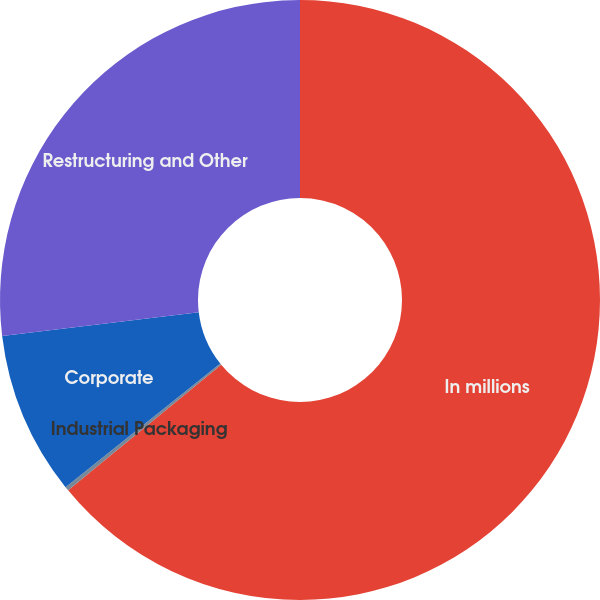Convert chart. <chart><loc_0><loc_0><loc_500><loc_500><pie_chart><fcel>In millions<fcel>Industrial Packaging<fcel>Corporate<fcel>Restructuring and Other<nl><fcel>64.06%<fcel>0.22%<fcel>8.81%<fcel>26.91%<nl></chart> 